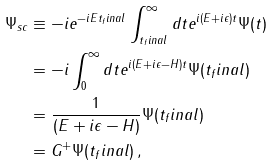<formula> <loc_0><loc_0><loc_500><loc_500>\Psi _ { s c } & \equiv - i e ^ { - i E t _ { f } i n a l } \int _ { t { _ { f } i n a l } } ^ { \infty } d t e ^ { i ( E + i \epsilon ) t } \Psi ( t ) \\ & = - i \int _ { 0 } ^ { \infty } d t e ^ { i ( E + i \epsilon - H ) t } \Psi ( t _ { f } i n a l ) \\ & = \frac { 1 } { ( E + i \epsilon - H ) } \Psi ( t _ { f } i n a l ) \\ & = G ^ { + } \Psi ( t _ { f } i n a l ) \, ,</formula> 